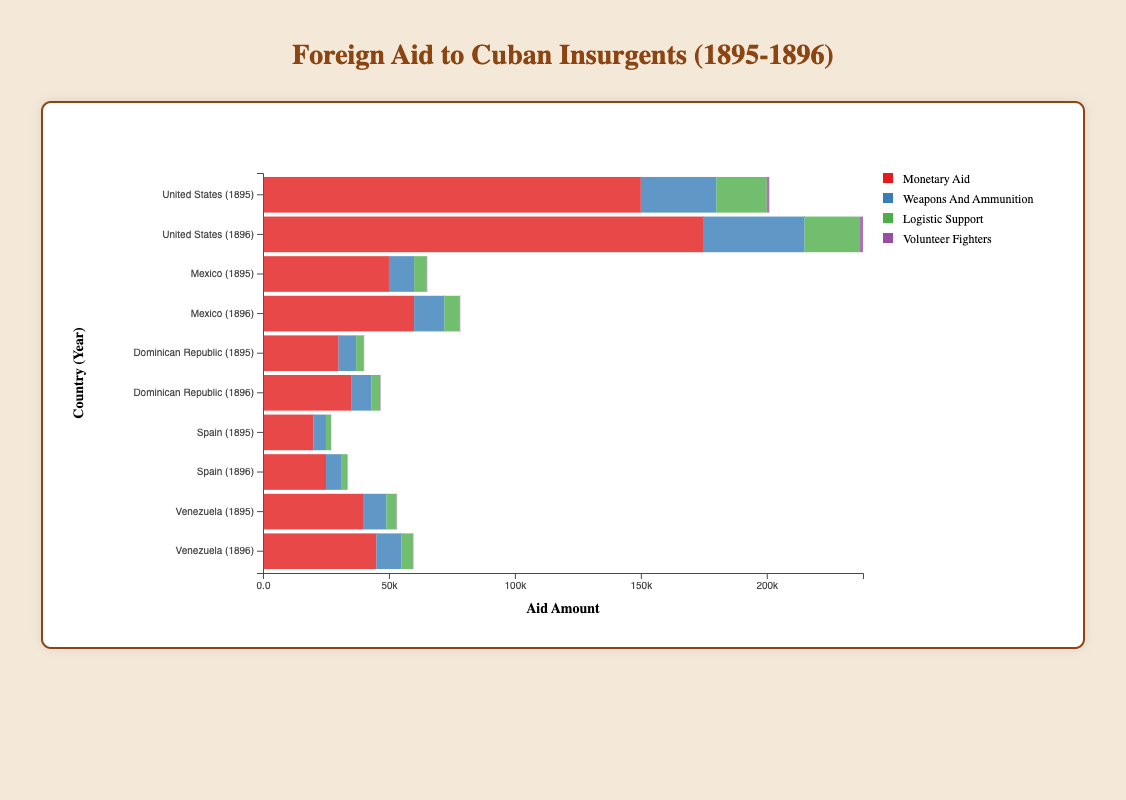How much total aid did Cuba receive from the United States in 1895? Add up all categories of aid from the United States in 1895: monetary aid (150,000) + weapons and ammunition (30,000) + logistic support (20,000) + volunteer fighters (1,000). The total is 150,000 + 30,000 + 20,000 + 1,000 = 201,000
Answer: 201,000 Which country provided the most volunteer fighters in 1896? Compare the number of volunteer fighters from each country in 1896: United States (1,200), Mexico (300), Dominican Republic (200), Spain (120), Venezuela (220). The United States provided the most volunteer fighters with 1,200
Answer: United States Compare the total monetary aid provided by Mexico in 1895 and 1896. Which year had more aid and by how much? In 1895, Mexico provided 50,000 in monetary aid. In 1896, Mexico provided 60,000. The difference is 60,000 - 50,000 = 10,000 more in 1896
Answer: 1896, 10,000 What type of aid (among monetary aid, weapons and ammunition, logistic support, volunteer fighters) did the Dominican Republic provide the least in 1896? Compare the amount of different types of aid provided by the Dominican Republic in 1896: monetary aid (35,000), weapons and ammunition (8,000), logistic support (3,500), volunteer fighters (200). Logistic support is the least with 3,500
Answer: Logistic support What is the total amount of aid (all categories combined) provided by Spain in 1895? Add up all categories of aid from Spain in 1895: monetary aid (20,000) + weapons and ammunition (5,000) + logistic support (2,000) + volunteer fighters (100). The total is 20,000 + 5,000 + 2,000 + 100 = 27,100
Answer: 27,100 Which country provided the highest amount of weapons and ammunition overall in 1896? Compare the amount of weapons and ammunition provided by each country in 1896: United States (40,000), Mexico (12,000), Dominican Republic (8,000), Spain (6,000), Venezuela (10,000). The United States provided the highest amount with 40,000
Answer: United States How much more logistic support did the United States provide in 1896 compared to Venezuela in 1896? The United States provided 22,000 in logistic support in 1896. Venezuela provided 4,500 in logistic support in 1896. The difference is 22,000 - 4,500 = 17,500
Answer: 17,500 In 1895, which country provided the least amount of monetary aid to Cuba, and how much was it? Compare the monetary aid provided by each country in 1895: United States (150,000), Mexico (50,000), Dominican Republic (30,000), Spain (20,000), Venezuela (40,000). Spain provided the least amount with 20,000
Answer: Spain, 20,000 What's the combined total of weapons and ammunition aid provided by the United States in both 1895 and 1896? Add up the weapons and ammunition aid provided by the United States in 1895 (30,000) and 1896 (40,000). The total is 30,000 + 40,000 = 70,000
Answer: 70,000 